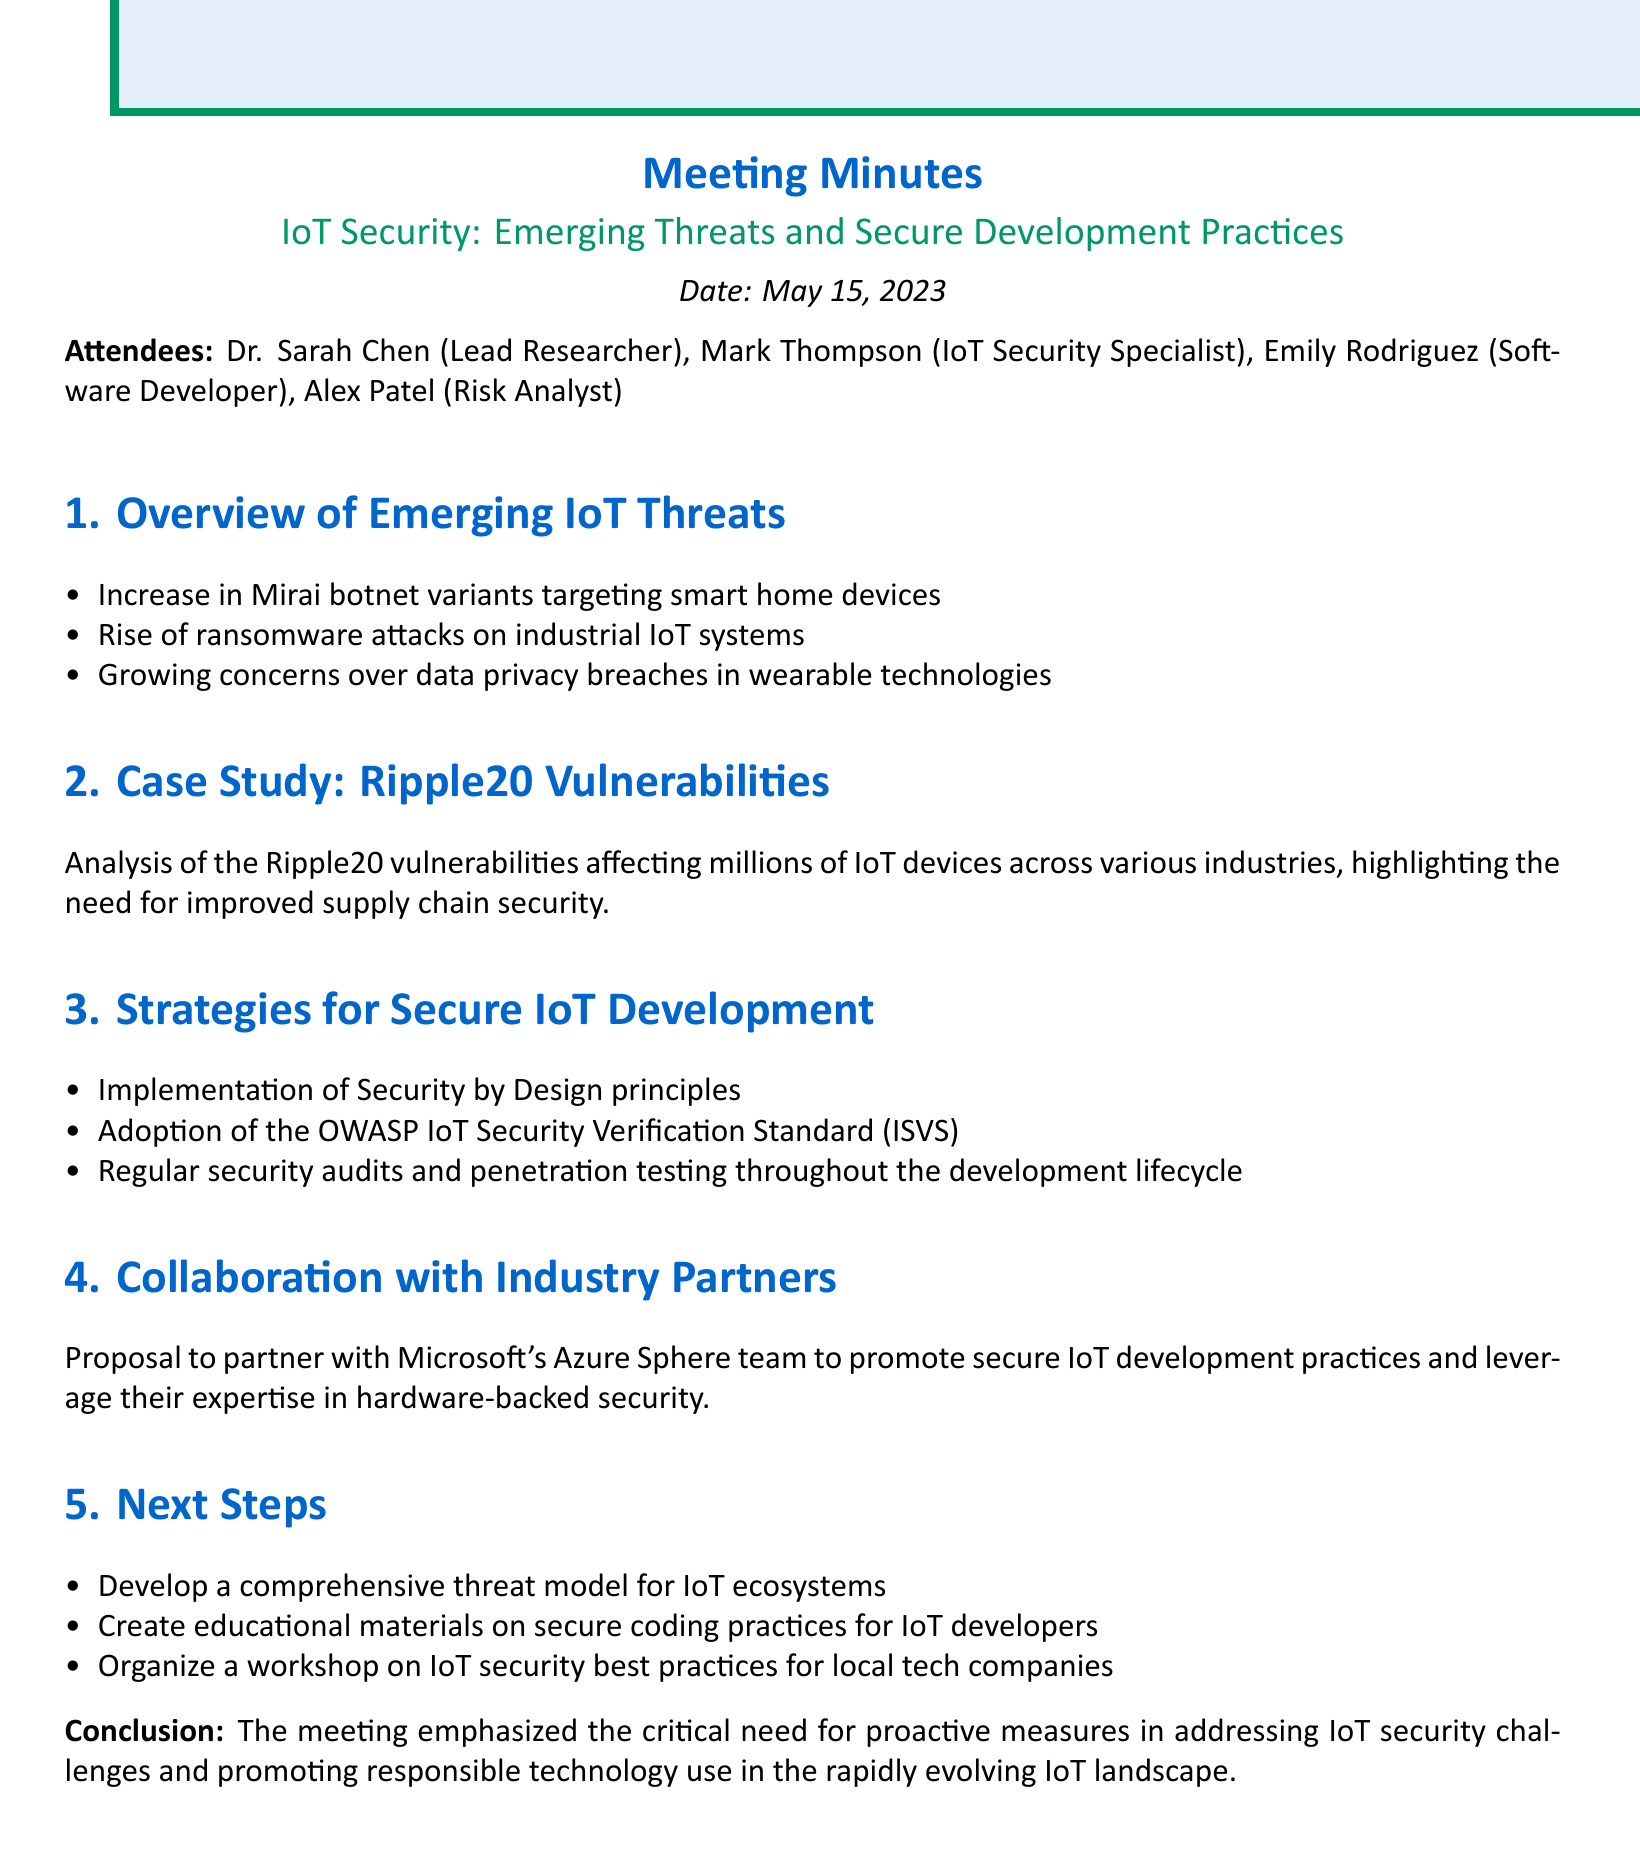What is the meeting title? The meeting title is explicitly stated at the beginning of the document.
Answer: IoT Security: Emerging Threats and Secure Development Practices What date was the meeting held? The date of the meeting is mentioned underneath the title.
Answer: May 15, 2023 Who is the Lead Researcher? The attendees section lists the roles and names of the attendees, identifying the Lead Researcher.
Answer: Dr. Sarah Chen What are the key points discussed under Emerging IoT Threats? The document presents the emerging threats in a bulleted list under the specified agenda item.
Answer: Increase in Mirai botnet variants targeting smart home devices, Rise of ransomware attacks on industrial IoT systems, Growing concerns over data privacy breaches in wearable technologies What is one strategy for secure IoT development mentioned? The Strategies for Secure IoT Development section highlights several strategies presented in bullet points.
Answer: Implementation of Security by Design principles How many action items are listed in the Next Steps? The action items in the Next Steps section can be counted, providing a clear number.
Answer: 3 What case study was analyzed during the meeting? The case study is named in the title of an agenda item discussing vulnerabilities.
Answer: Ripple20 Vulnerabilities With whom is the collaboration proposed? The document specifies the partner organization in the Collaboration with Industry Partners section.
Answer: Microsoft's Azure Sphere team What is the conclusion of the meeting? The conclusion summarizes the overall focus of the meeting on security challenges and technology use.
Answer: The meeting emphasized the critical need for proactive measures in addressing IoT security challenges and promoting responsible technology use in the rapidly evolving IoT landscape 